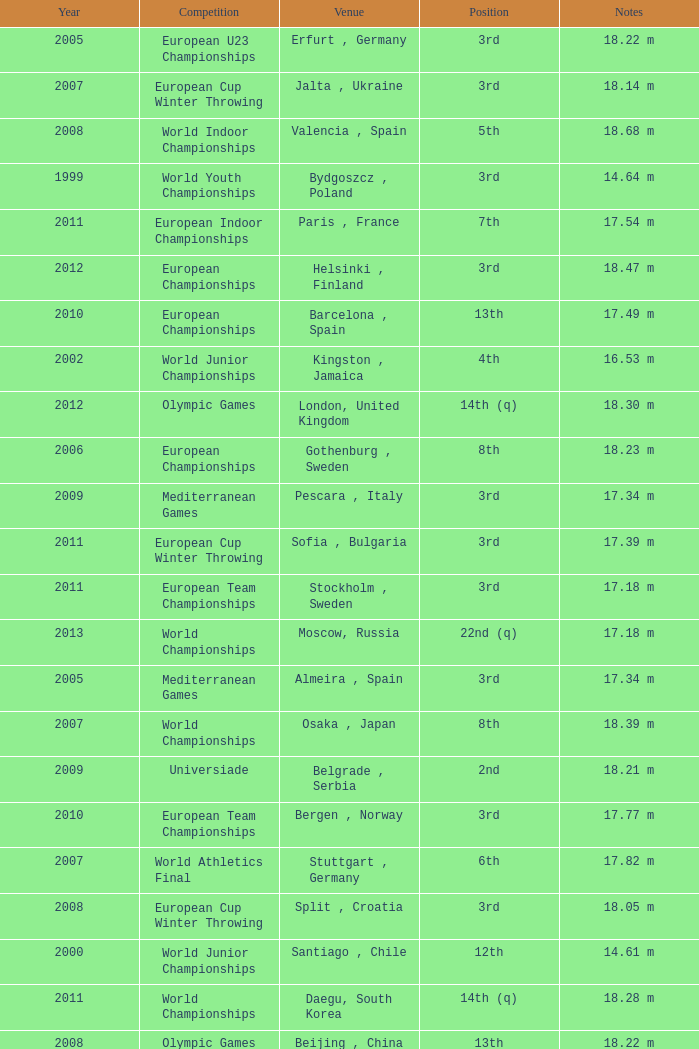What are the notes for bydgoszcz, Poland? 14.64 m, 16.49 m. 